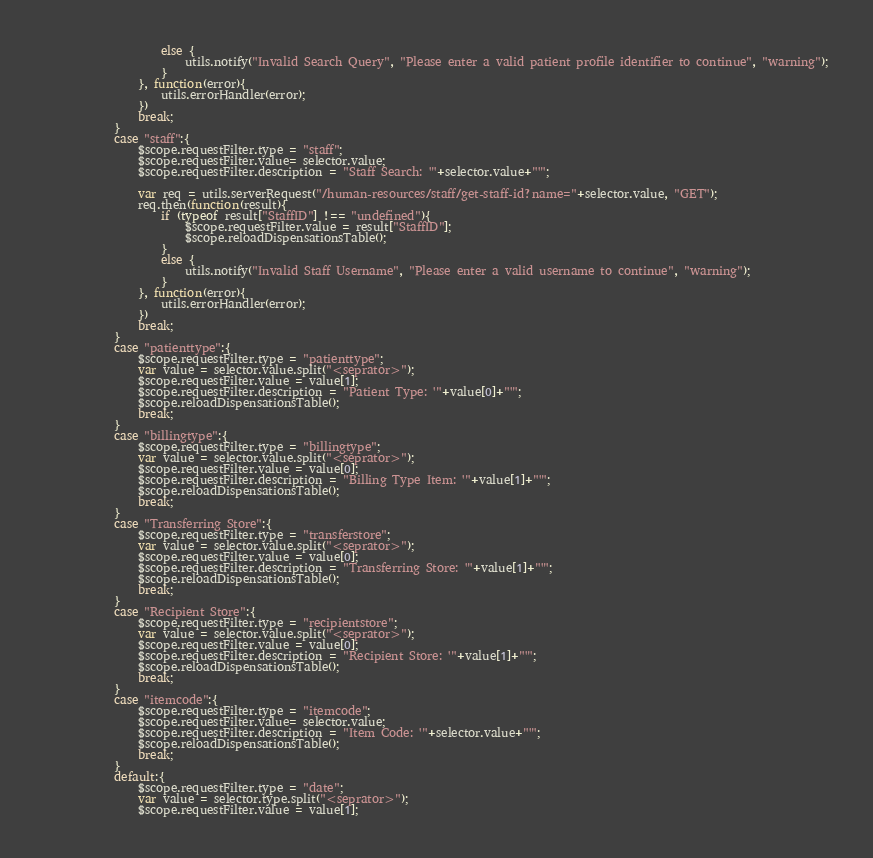Convert code to text. <code><loc_0><loc_0><loc_500><loc_500><_JavaScript_>					else {
						utils.notify("Invalid Search Query", "Please enter a valid patient profile identifier to continue", "warning");
					}
				}, function(error){
					utils.errorHandler(error);
				})
				break;
			}
			case "staff":{
				$scope.requestFilter.type = "staff";
				$scope.requestFilter.value= selector.value;
				$scope.requestFilter.description = "Staff Search: '"+selector.value+"'";

				var req = utils.serverRequest("/human-resources/staff/get-staff-id?name="+selector.value, "GET");
				req.then(function(result){
					if (typeof result["StaffID"] !== "undefined"){
						$scope.requestFilter.value = result["StaffID"];
						$scope.reloadDispensationsTable();
					}
					else {
						utils.notify("Invalid Staff Username", "Please enter a valid username to continue", "warning");
					}
				}, function(error){
					utils.errorHandler(error);
				})
				break;
			}
			case "patienttype":{
				$scope.requestFilter.type = "patienttype";
				var value = selector.value.split("<seprator>");
				$scope.requestFilter.value = value[1];
				$scope.requestFilter.description = "Patient Type: '"+value[0]+"'";
				$scope.reloadDispensationsTable();
				break;
			}
			case "billingtype":{
				$scope.requestFilter.type = "billingtype";
				var value = selector.value.split("<seprator>");
				$scope.requestFilter.value = value[0];
				$scope.requestFilter.description = "Billing Type Item: '"+value[1]+"'";
				$scope.reloadDispensationsTable();
				break;
			}
			case "Transferring Store":{
				$scope.requestFilter.type = "transferstore";
				var value = selector.value.split("<seprator>");
				$scope.requestFilter.value = value[0];
				$scope.requestFilter.description = "Transferring Store: '"+value[1]+"'";
				$scope.reloadDispensationsTable();
				break;
			}
			case "Recipient Store":{
				$scope.requestFilter.type = "recipientstore";
				var value = selector.value.split("<seprator>");
				$scope.requestFilter.value = value[0];
				$scope.requestFilter.description = "Recipient Store: '"+value[1]+"'";
				$scope.reloadDispensationsTable();
				break;
			}
			case "itemcode":{
				$scope.requestFilter.type = "itemcode";
				$scope.requestFilter.value= selector.value;
				$scope.requestFilter.description = "Item Code: '"+selector.value+"'";
				$scope.reloadDispensationsTable();
				break;
			}
			default:{
				$scope.requestFilter.type = "date";
				var value = selector.type.split("<seprator>");
				$scope.requestFilter.value = value[1];</code> 